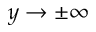Convert formula to latex. <formula><loc_0><loc_0><loc_500><loc_500>y \rightarrow \pm \infty</formula> 